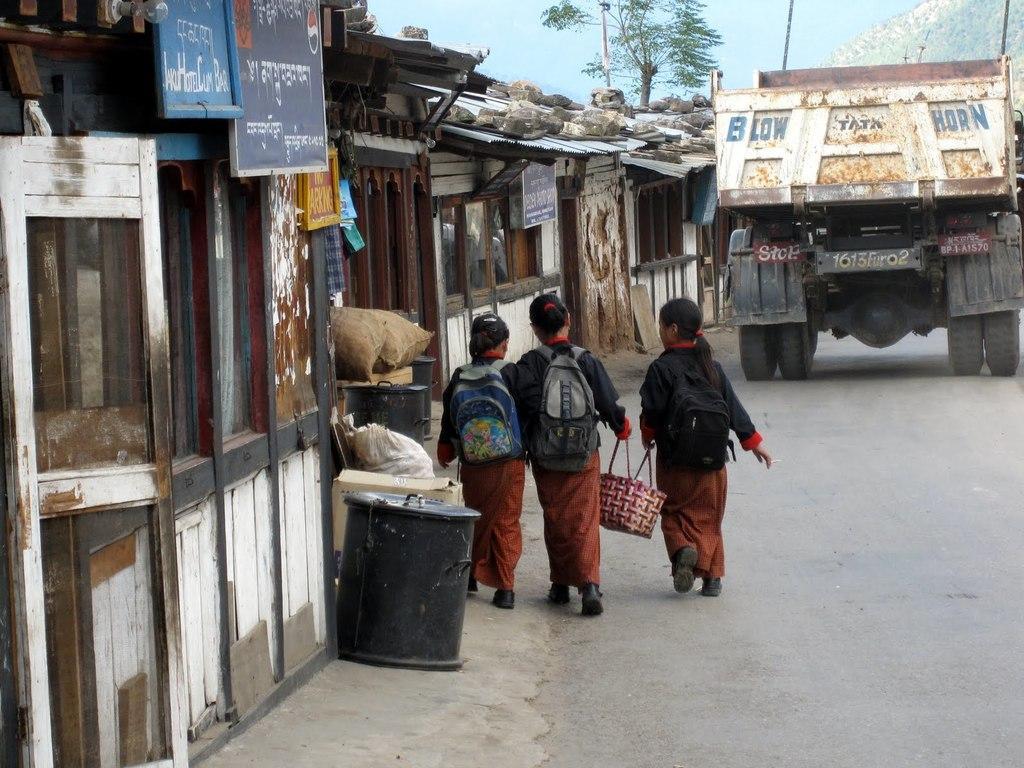Describe this image in one or two sentences. As we can see in the image there is a road on which lorry is moving and three girls are walking by carrying a bag pack and holding a two girls are holding a bag. Beside them there is a houses and back of the girls there is a black drum in front of it there is a cardboard box. 